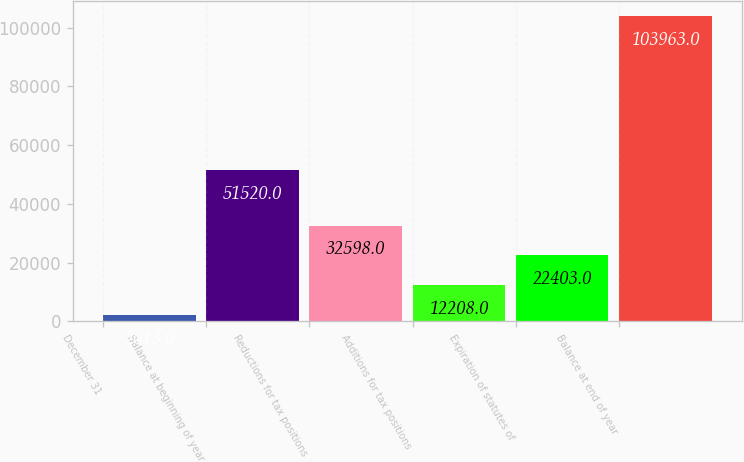<chart> <loc_0><loc_0><loc_500><loc_500><bar_chart><fcel>December 31<fcel>Balance at beginning of year<fcel>Reductions for tax positions<fcel>Additions for tax positions<fcel>Expiration of statutes of<fcel>Balance at end of year<nl><fcel>2013<fcel>51520<fcel>32598<fcel>12208<fcel>22403<fcel>103963<nl></chart> 